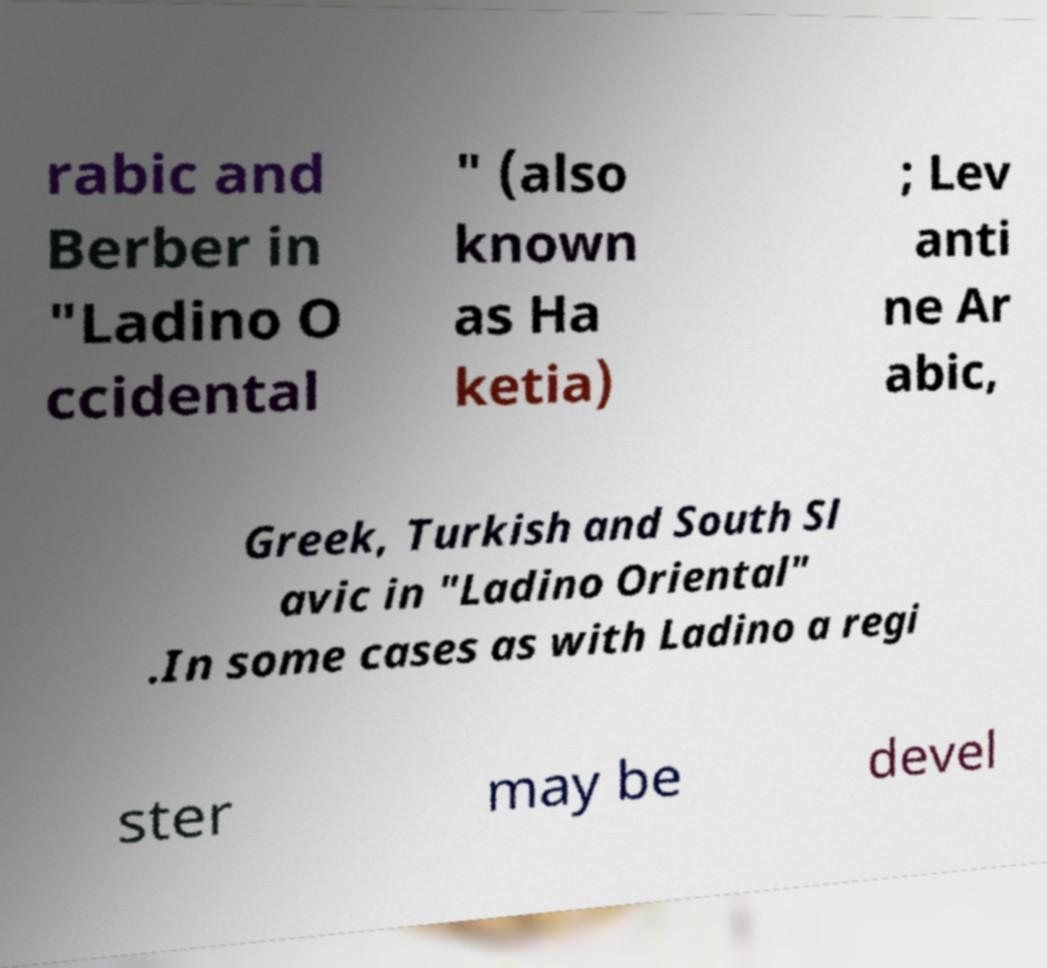Please identify and transcribe the text found in this image. rabic and Berber in "Ladino O ccidental " (also known as Ha ketia) ; Lev anti ne Ar abic, Greek, Turkish and South Sl avic in "Ladino Oriental" .In some cases as with Ladino a regi ster may be devel 